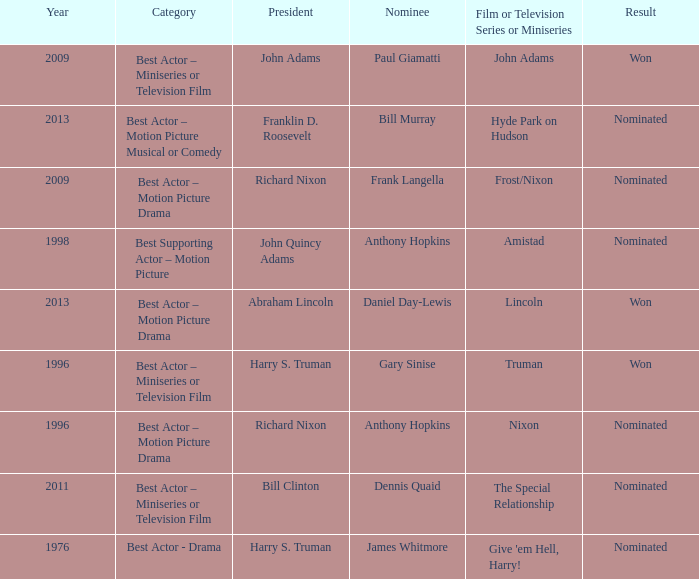What was the result of Frank Langella? Nominated. 